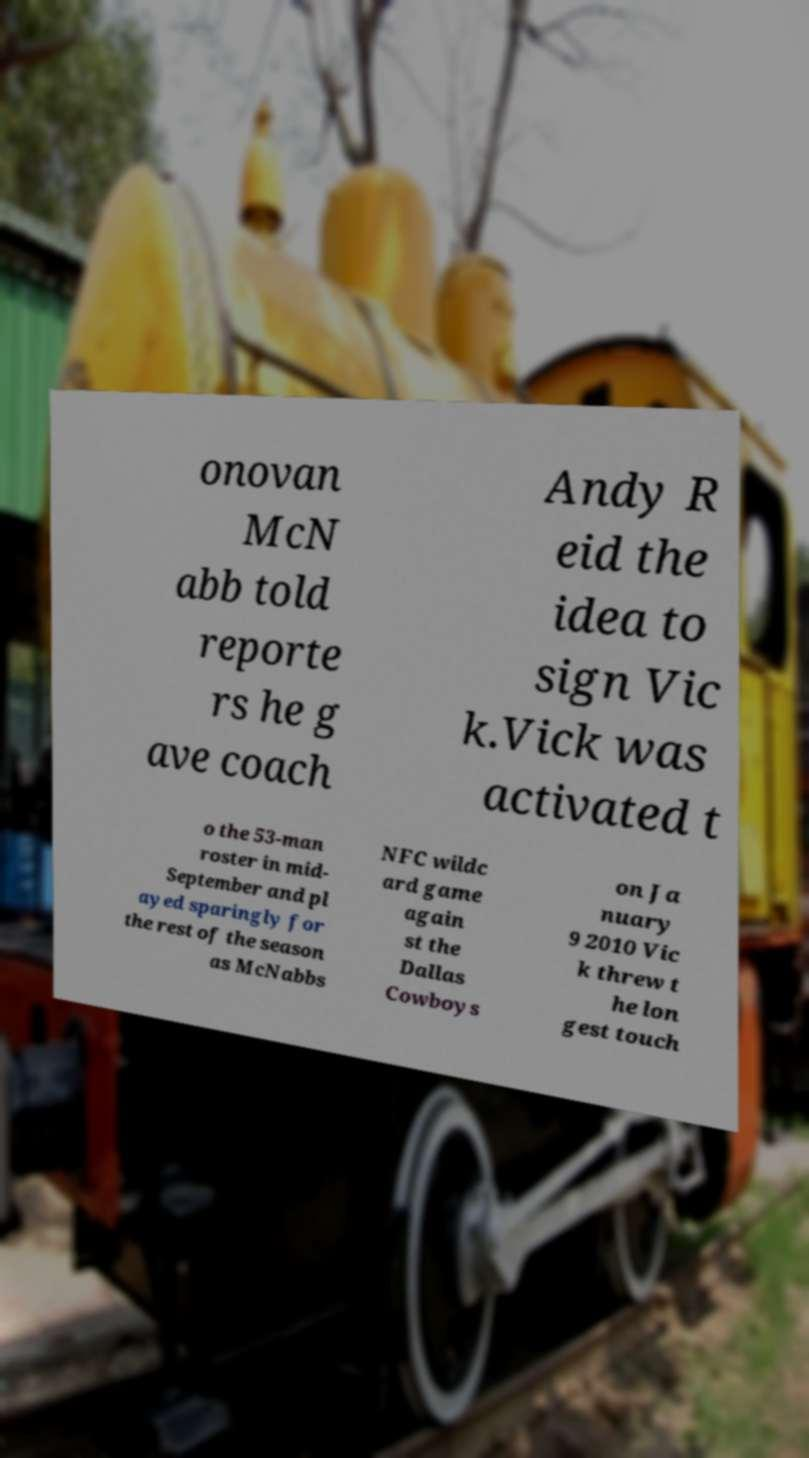Could you extract and type out the text from this image? onovan McN abb told reporte rs he g ave coach Andy R eid the idea to sign Vic k.Vick was activated t o the 53-man roster in mid- September and pl ayed sparingly for the rest of the season as McNabbs NFC wildc ard game again st the Dallas Cowboys on Ja nuary 9 2010 Vic k threw t he lon gest touch 